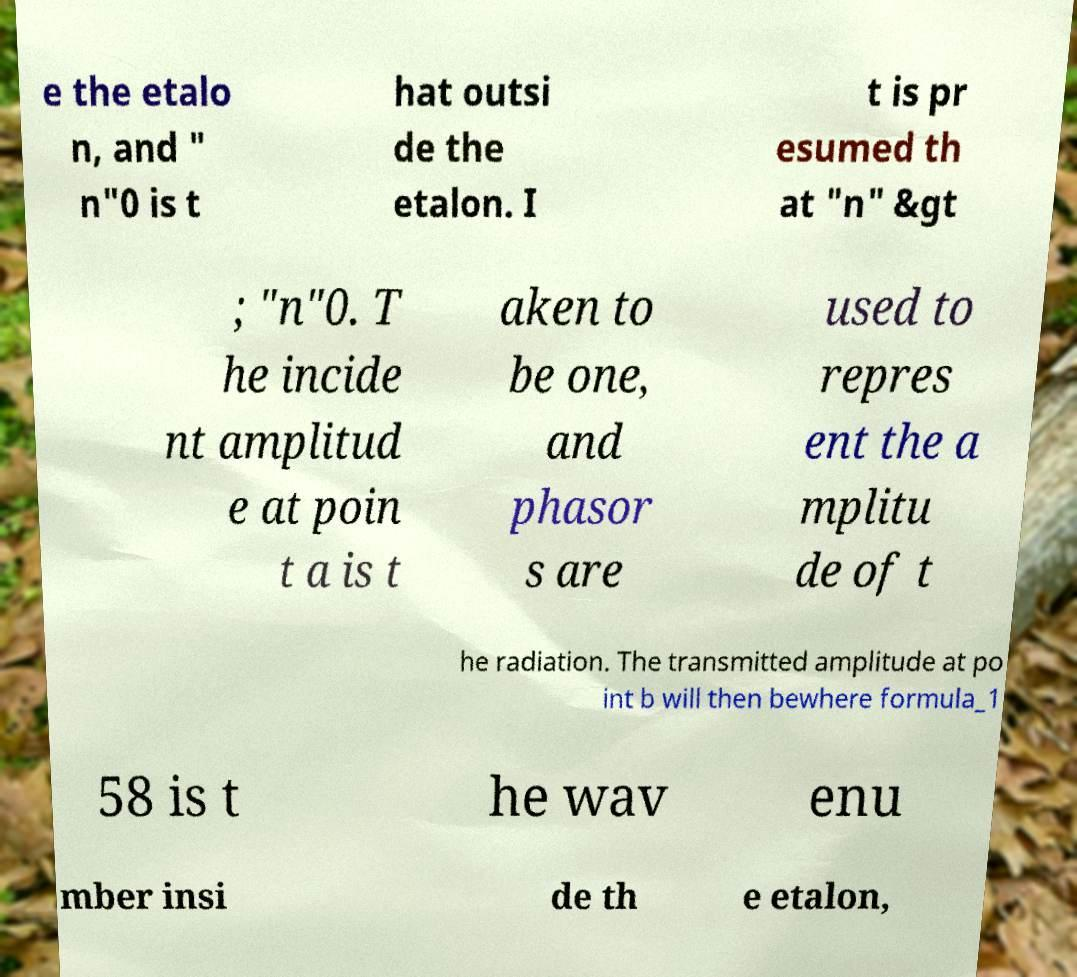What messages or text are displayed in this image? I need them in a readable, typed format. e the etalo n, and " n"0 is t hat outsi de the etalon. I t is pr esumed th at "n" &gt ; "n"0. T he incide nt amplitud e at poin t a is t aken to be one, and phasor s are used to repres ent the a mplitu de of t he radiation. The transmitted amplitude at po int b will then bewhere formula_1 58 is t he wav enu mber insi de th e etalon, 